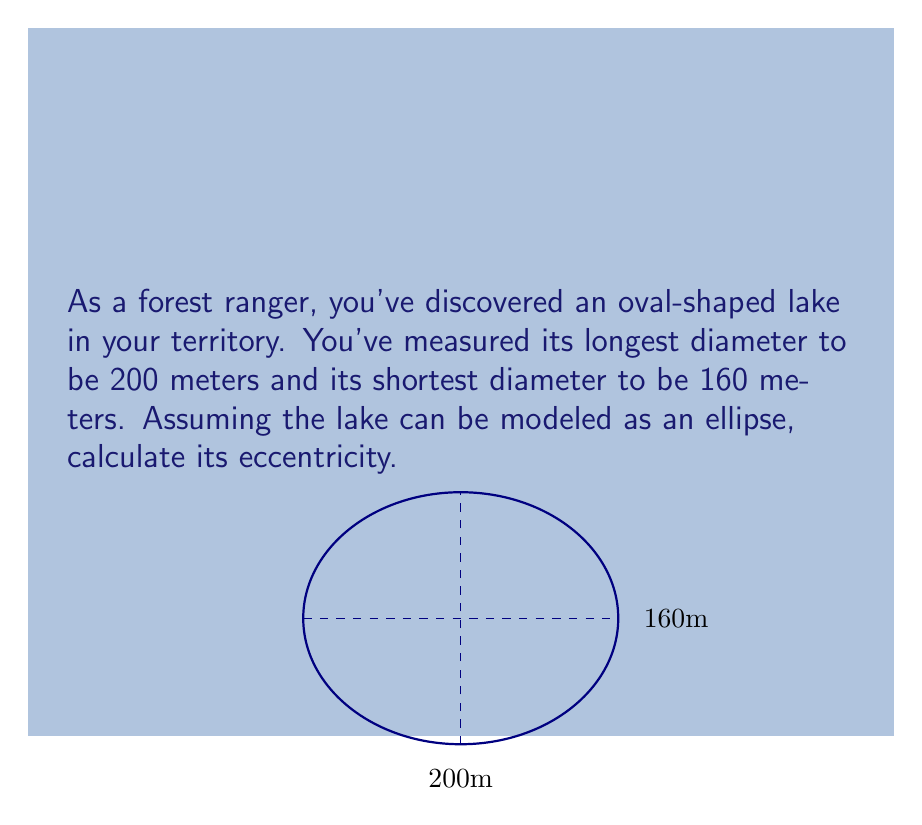What is the answer to this math problem? Let's approach this step-by-step:

1) The eccentricity (e) of an ellipse is given by the formula:

   $$e = \sqrt{1 - \frac{b^2}{a^2}}$$

   where $a$ is the semi-major axis (half of the longest diameter) and $b$ is the semi-minor axis (half of the shortest diameter).

2) From the given information:
   - Longest diameter = 200 m, so $a = 100$ m
   - Shortest diameter = 160 m, so $b = 80$ m

3) Let's substitute these values into the formula:

   $$e = \sqrt{1 - \frac{80^2}{100^2}}$$

4) Simplify inside the fraction:
   
   $$e = \sqrt{1 - \frac{6400}{10000}}$$

5) Perform the division:

   $$e = \sqrt{1 - 0.64}$$

6) Subtract:

   $$e = \sqrt{0.36}$$

7) Take the square root:

   $$e = 0.6$$

Thus, the eccentricity of the lake is 0.6.
Answer: $0.6$ 